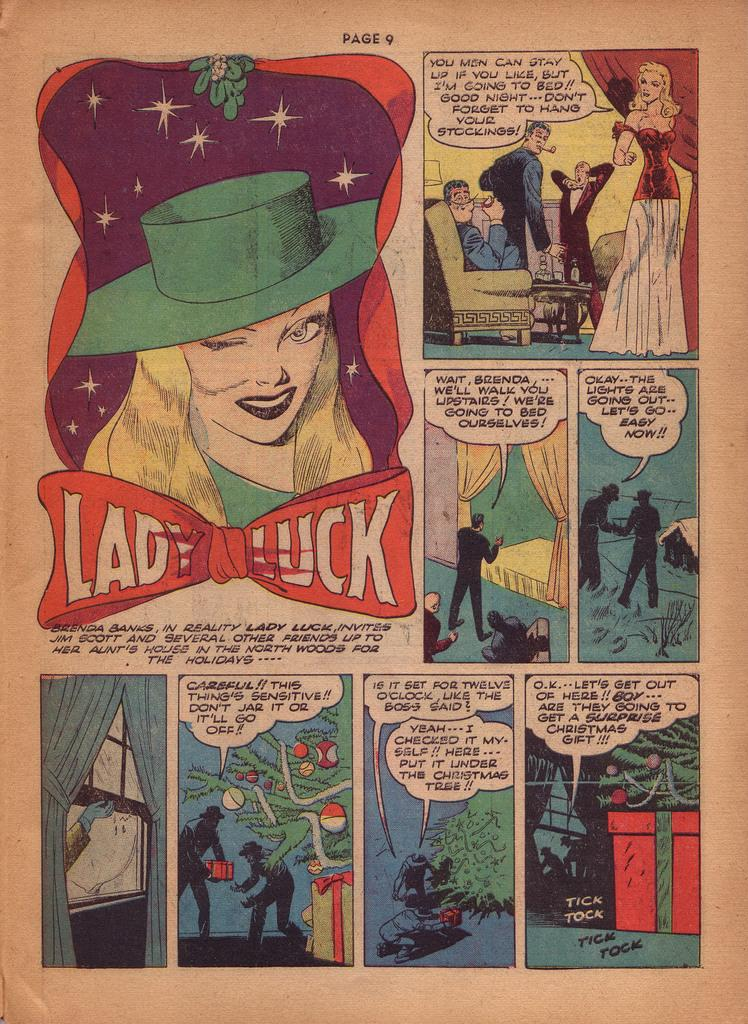<image>
Provide a brief description of the given image. Comic book showing Lady Luck on page 9. 